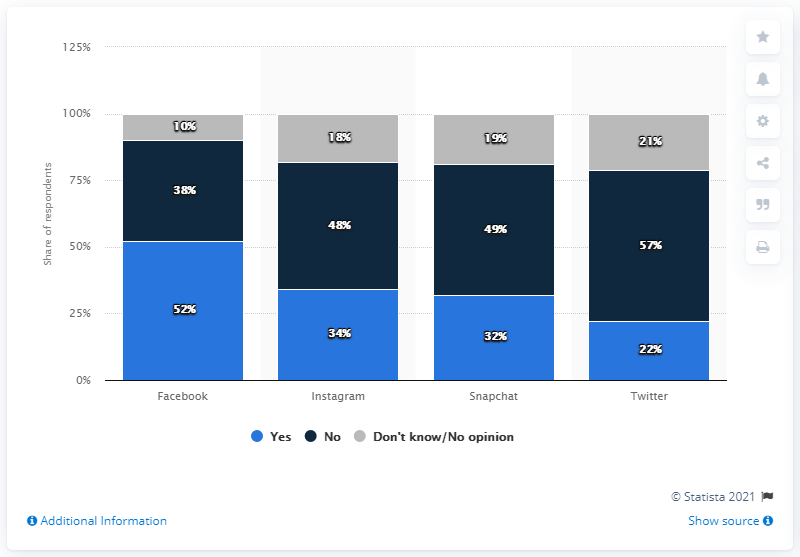Specify some key components in this picture. The average percentage of Yes in all the bars is 35%. Yes percentage in Facebook refers to the percentage of users who have selected the "Yes" option in a particular Facebook survey or poll. The most prevalent social media platform that parents were aware of their children having was Facebook. 